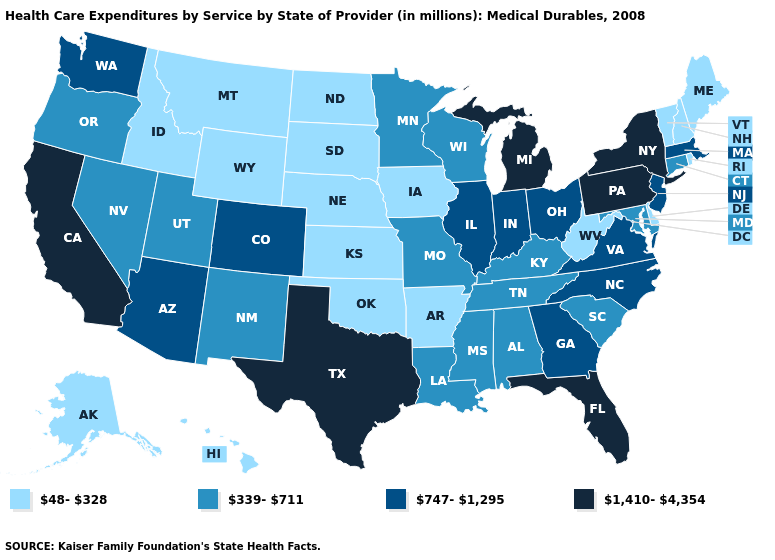Name the states that have a value in the range 747-1,295?
Keep it brief. Arizona, Colorado, Georgia, Illinois, Indiana, Massachusetts, New Jersey, North Carolina, Ohio, Virginia, Washington. Name the states that have a value in the range 48-328?
Give a very brief answer. Alaska, Arkansas, Delaware, Hawaii, Idaho, Iowa, Kansas, Maine, Montana, Nebraska, New Hampshire, North Dakota, Oklahoma, Rhode Island, South Dakota, Vermont, West Virginia, Wyoming. Which states have the lowest value in the USA?
Keep it brief. Alaska, Arkansas, Delaware, Hawaii, Idaho, Iowa, Kansas, Maine, Montana, Nebraska, New Hampshire, North Dakota, Oklahoma, Rhode Island, South Dakota, Vermont, West Virginia, Wyoming. What is the highest value in the MidWest ?
Quick response, please. 1,410-4,354. Name the states that have a value in the range 1,410-4,354?
Give a very brief answer. California, Florida, Michigan, New York, Pennsylvania, Texas. Among the states that border Arkansas , does Texas have the highest value?
Answer briefly. Yes. Does Ohio have the lowest value in the MidWest?
Answer briefly. No. What is the highest value in states that border Montana?
Be succinct. 48-328. Does Indiana have the lowest value in the USA?
Write a very short answer. No. What is the highest value in states that border Montana?
Keep it brief. 48-328. Name the states that have a value in the range 48-328?
Be succinct. Alaska, Arkansas, Delaware, Hawaii, Idaho, Iowa, Kansas, Maine, Montana, Nebraska, New Hampshire, North Dakota, Oklahoma, Rhode Island, South Dakota, Vermont, West Virginia, Wyoming. What is the value of Wisconsin?
Answer briefly. 339-711. Name the states that have a value in the range 1,410-4,354?
Write a very short answer. California, Florida, Michigan, New York, Pennsylvania, Texas. Which states hav the highest value in the Northeast?
Quick response, please. New York, Pennsylvania. Does the map have missing data?
Write a very short answer. No. 